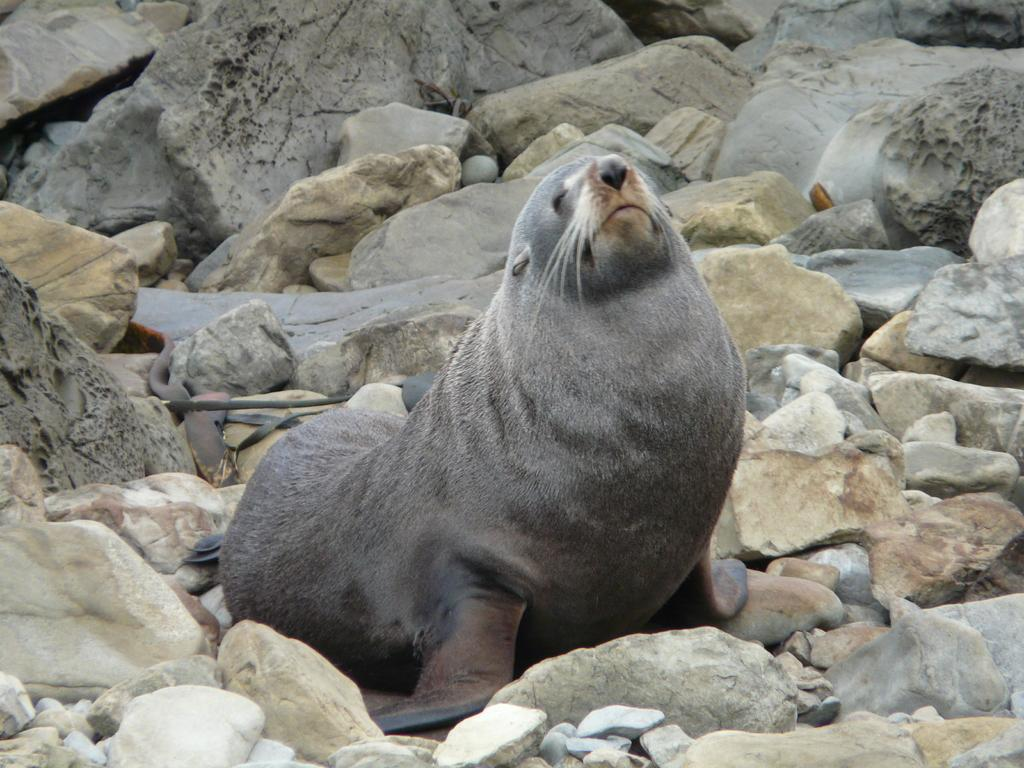What animal is the main subject of the image? There is a sea lion in the image. What is the sea lion sitting on? The sea lion is sitting on stones. What can be seen in the background of the image? There are belts visible in the background of the image. What type of flesh can be seen growing on the sea lion in the image? There is no flesh growing on the sea lion in the image; it is a healthy sea lion sitting on stones. How does the wind affect the sea lion's behavior in the image? The image does not depict any wind or its effects on the sea lion's behavior. 